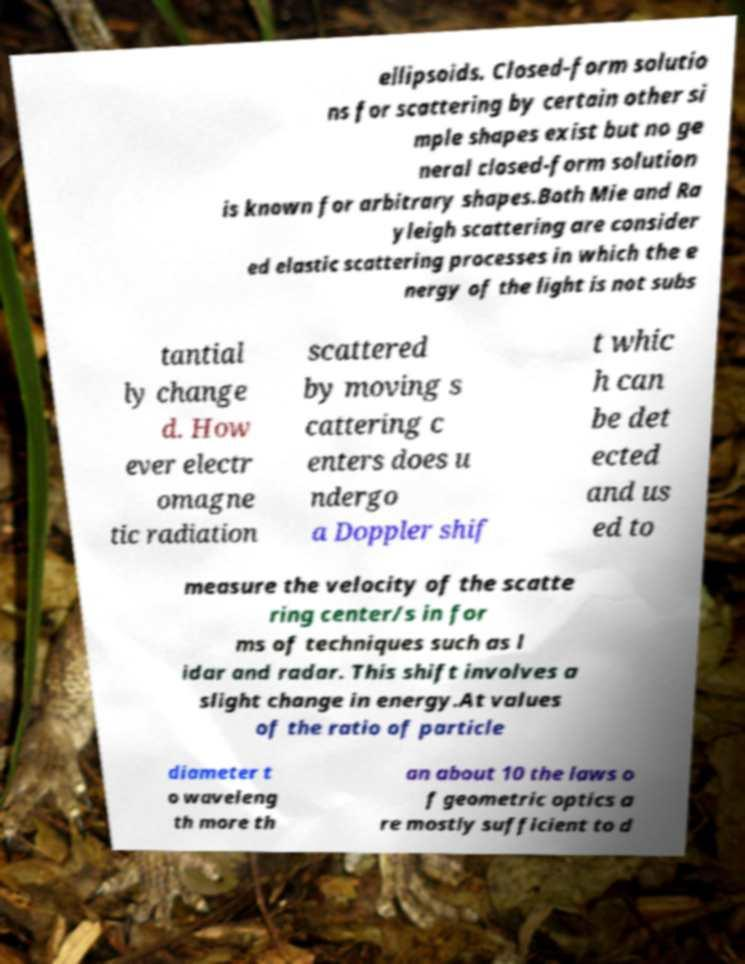Please identify and transcribe the text found in this image. ellipsoids. Closed-form solutio ns for scattering by certain other si mple shapes exist but no ge neral closed-form solution is known for arbitrary shapes.Both Mie and Ra yleigh scattering are consider ed elastic scattering processes in which the e nergy of the light is not subs tantial ly change d. How ever electr omagne tic radiation scattered by moving s cattering c enters does u ndergo a Doppler shif t whic h can be det ected and us ed to measure the velocity of the scatte ring center/s in for ms of techniques such as l idar and radar. This shift involves a slight change in energy.At values of the ratio of particle diameter t o waveleng th more th an about 10 the laws o f geometric optics a re mostly sufficient to d 